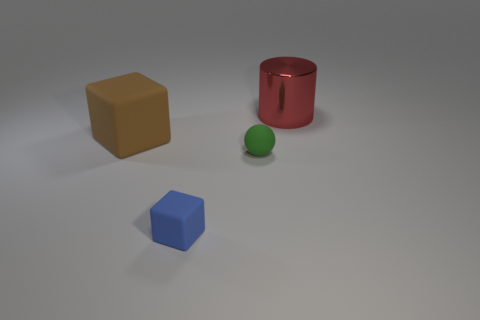What is the brown block made of?
Keep it short and to the point. Rubber. Is there a small purple object?
Your answer should be very brief. No. Is the number of balls that are on the left side of the blue block the same as the number of large red shiny objects?
Offer a terse response. No. Is there any other thing that has the same material as the large red thing?
Keep it short and to the point. No. What number of tiny objects are cyan metal cylinders or brown matte objects?
Make the answer very short. 0. Does the large object that is to the left of the tiny green rubber thing have the same material as the large red cylinder?
Provide a succinct answer. No. There is a big object to the right of the big thing in front of the big red object; what is it made of?
Your answer should be compact. Metal. How many other big red objects have the same shape as the large metal object?
Make the answer very short. 0. There is a object on the right side of the small green rubber object in front of the large object left of the red object; what is its size?
Your answer should be compact. Large. How many brown objects are either metal blocks or matte objects?
Offer a very short reply. 1. 